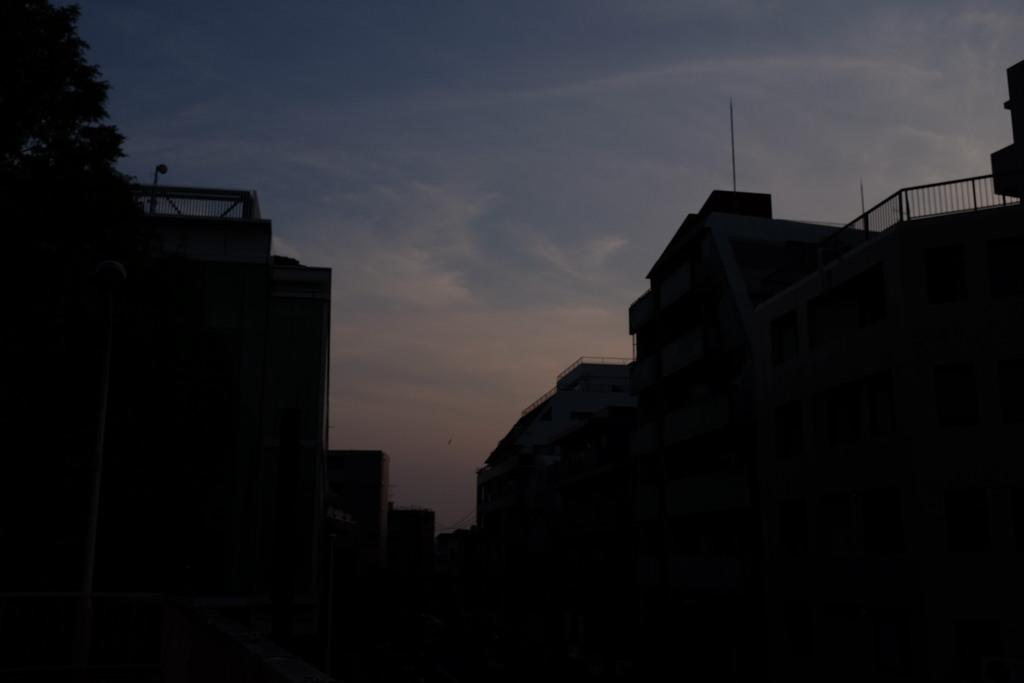What type of structures can be seen in the image? There are buildings in the image. What type of plant is present in the image? There is a tree in the image. What type of barrier is visible in the image? There is a fence in the image. What is visible in the background of the image? The sky is visible in the background of the image. How would you describe the lighting in the image? The image appears to be slightly dark. Can you tell me how many cans of soda are placed on the fence in the image? There is no mention of soda or cans in the image; it features buildings, a tree, a fence, and the sky. What type of thrill can be experienced by the tree in the image? The tree is not capable of experiencing thrill; it is a stationary object in the image. 